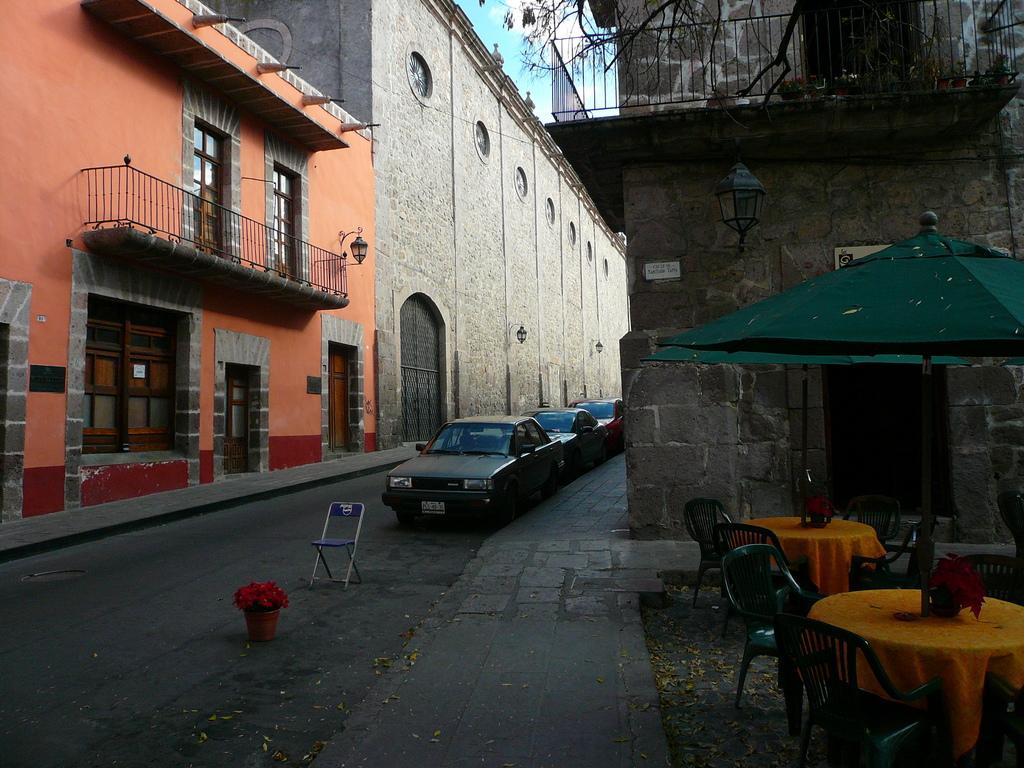In one or two sentences, can you explain what this image depicts? On both side of the image, there are buildings visible of orange and white in color. On the top middle, a sky is visible blue in color. In the middle bottom, cars are moving on the road and a chair is visible. In the right bottom, tables and chairs are visible under the umbrella hut which is green in color. This image is taken during day time on the road. 